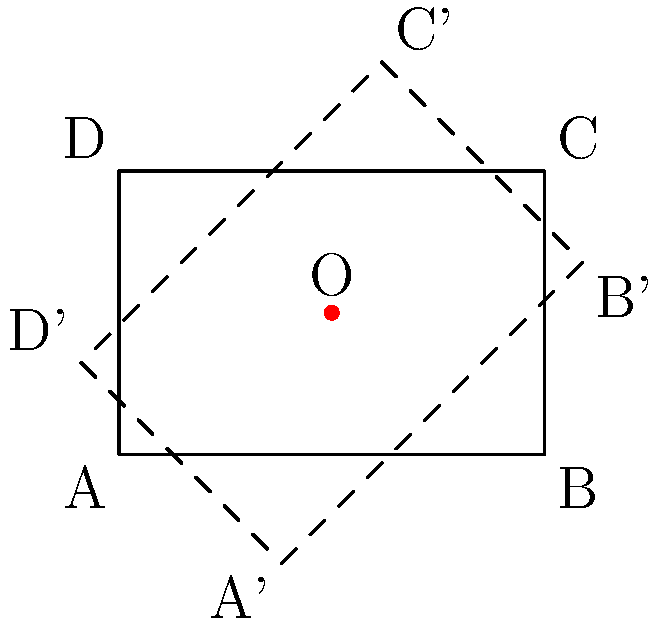A rectangular polygon ABCD with vertices A(0,0), B(3,0), C(3,2), and D(0,2) is rotated 45° counterclockwise around point O(1.5,1). Calculate the coordinates of vertex C after rotation. To solve this problem, we'll use the rotation matrix and follow these steps:

1) The rotation matrix for a counterclockwise rotation by angle θ around the origin is:
   $$R = \begin{bmatrix} \cos\theta & -\sin\theta \\ \sin\theta & \cos\theta \end{bmatrix}$$

2) For a 45° rotation, $\theta = 45° = \frac{\pi}{4}$ radians. So:
   $$R = \begin{bmatrix} \cos\frac{\pi}{4} & -\sin\frac{\pi}{4} \\ \sin\frac{\pi}{4} & \cos\frac{\pi}{4} \end{bmatrix} = \begin{bmatrix} \frac{\sqrt{2}}{2} & -\frac{\sqrt{2}}{2} \\ \frac{\sqrt{2}}{2} & \frac{\sqrt{2}}{2} \end{bmatrix}$$

3) To rotate around point O(1.5,1), we:
   a) Translate the polygon so O becomes the origin
   b) Apply the rotation
   c) Translate back

4) For point C(3,2):
   a) Translate: (3-1.5, 2-1) = (1.5, 1)
   b) Rotate:
      $$\begin{bmatrix} \frac{\sqrt{2}}{2} & -\frac{\sqrt{2}}{2} \\ \frac{\sqrt{2}}{2} & \frac{\sqrt{2}}{2} \end{bmatrix} \begin{bmatrix} 1.5 \\ 1 \end{bmatrix} = \begin{bmatrix} \frac{3\sqrt{2}}{4} - \frac{\sqrt{2}}{2} \\ \frac{3\sqrt{2}}{4} + \frac{\sqrt{2}}{2} \end{bmatrix} = \begin{bmatrix} \frac{\sqrt{2}}{4} \\ \frac{5\sqrt{2}}{4} \end{bmatrix}$$
   c) Translate back: $(\frac{\sqrt{2}}{4} + 1.5, \frac{5\sqrt{2}}{4} + 1)$

5) Simplify:
   $x = \frac{\sqrt{2}}{4} + 1.5 = 1.5 + 0.3535 = 1.8535$
   $y = \frac{5\sqrt{2}}{4} + 1 = 1 + 1.7678 = 2.7678$

Therefore, the coordinates of C after rotation are approximately (1.85, 2.77).
Answer: (1.85, 2.77) 